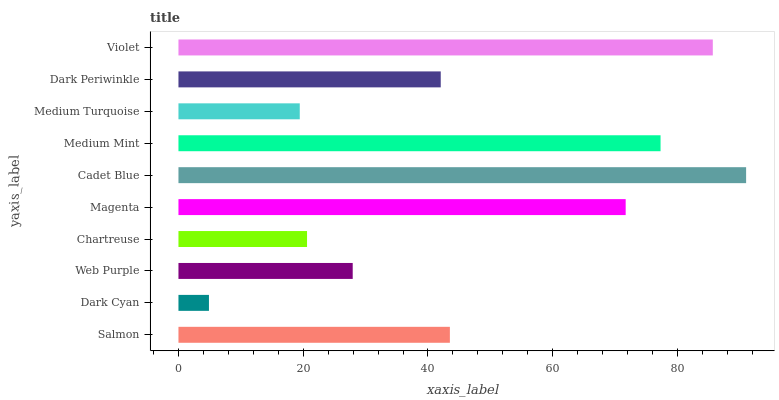Is Dark Cyan the minimum?
Answer yes or no. Yes. Is Cadet Blue the maximum?
Answer yes or no. Yes. Is Web Purple the minimum?
Answer yes or no. No. Is Web Purple the maximum?
Answer yes or no. No. Is Web Purple greater than Dark Cyan?
Answer yes or no. Yes. Is Dark Cyan less than Web Purple?
Answer yes or no. Yes. Is Dark Cyan greater than Web Purple?
Answer yes or no. No. Is Web Purple less than Dark Cyan?
Answer yes or no. No. Is Salmon the high median?
Answer yes or no. Yes. Is Dark Periwinkle the low median?
Answer yes or no. Yes. Is Dark Cyan the high median?
Answer yes or no. No. Is Salmon the low median?
Answer yes or no. No. 